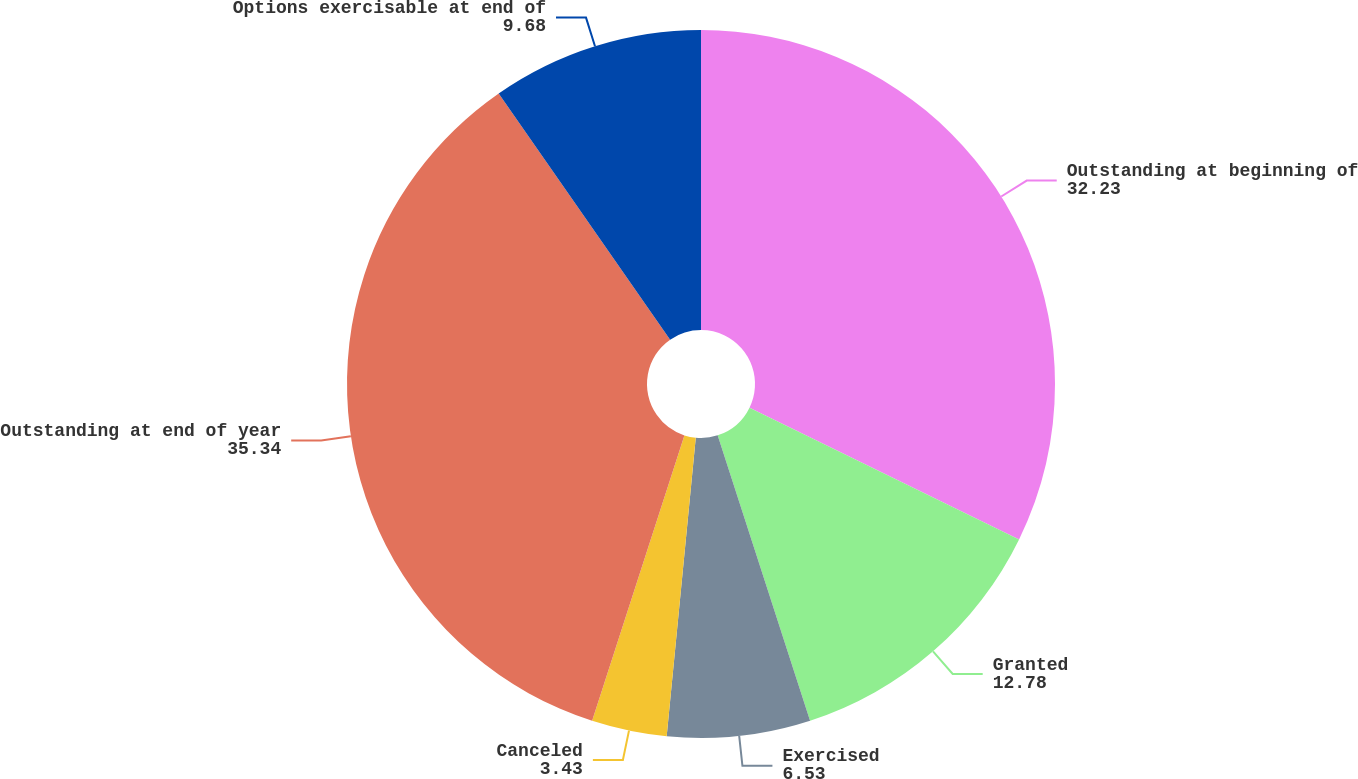<chart> <loc_0><loc_0><loc_500><loc_500><pie_chart><fcel>Outstanding at beginning of<fcel>Granted<fcel>Exercised<fcel>Canceled<fcel>Outstanding at end of year<fcel>Options exercisable at end of<nl><fcel>32.23%<fcel>12.78%<fcel>6.53%<fcel>3.43%<fcel>35.34%<fcel>9.68%<nl></chart> 